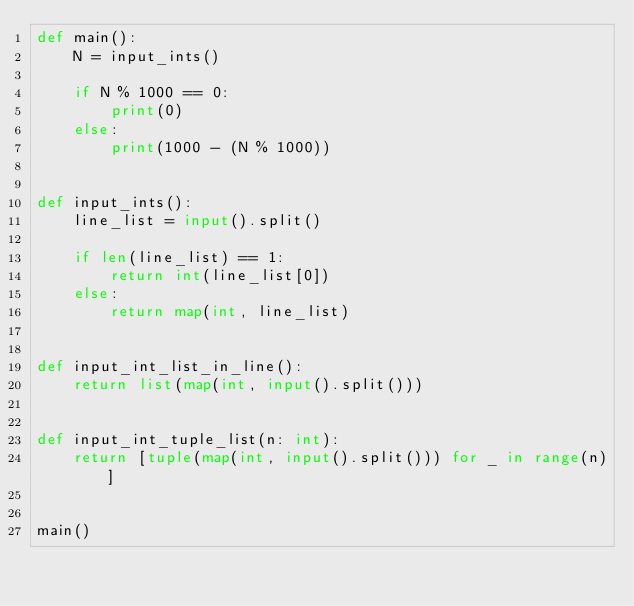Convert code to text. <code><loc_0><loc_0><loc_500><loc_500><_Python_>def main():
    N = input_ints()

    if N % 1000 == 0:
        print(0)
    else:
        print(1000 - (N % 1000))


def input_ints():
    line_list = input().split()

    if len(line_list) == 1:
        return int(line_list[0])
    else:
        return map(int, line_list)


def input_int_list_in_line():
    return list(map(int, input().split()))


def input_int_tuple_list(n: int):
    return [tuple(map(int, input().split())) for _ in range(n)]


main()
</code> 